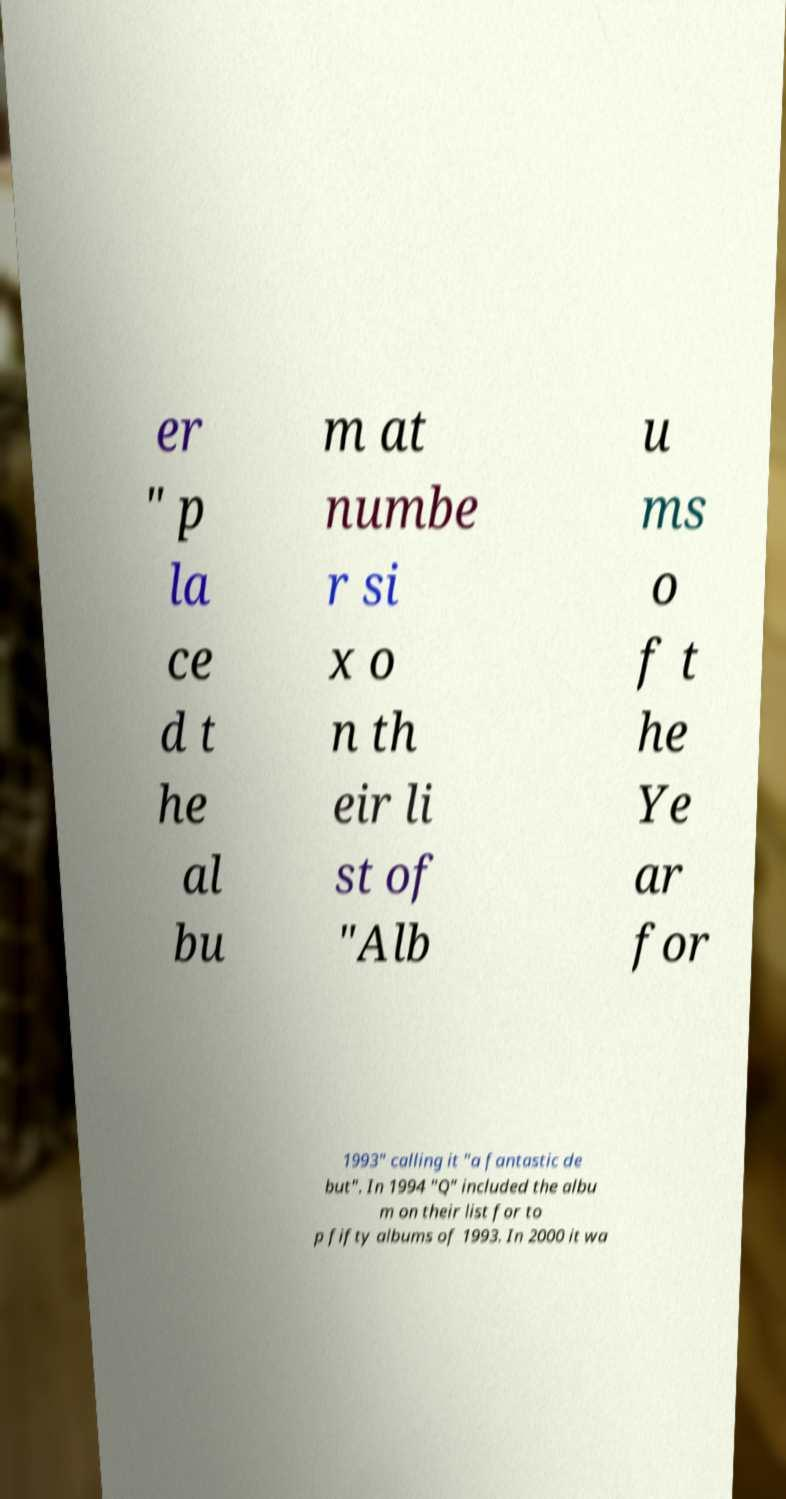Please read and relay the text visible in this image. What does it say? er " p la ce d t he al bu m at numbe r si x o n th eir li st of "Alb u ms o f t he Ye ar for 1993" calling it "a fantastic de but". In 1994 "Q" included the albu m on their list for to p fifty albums of 1993. In 2000 it wa 